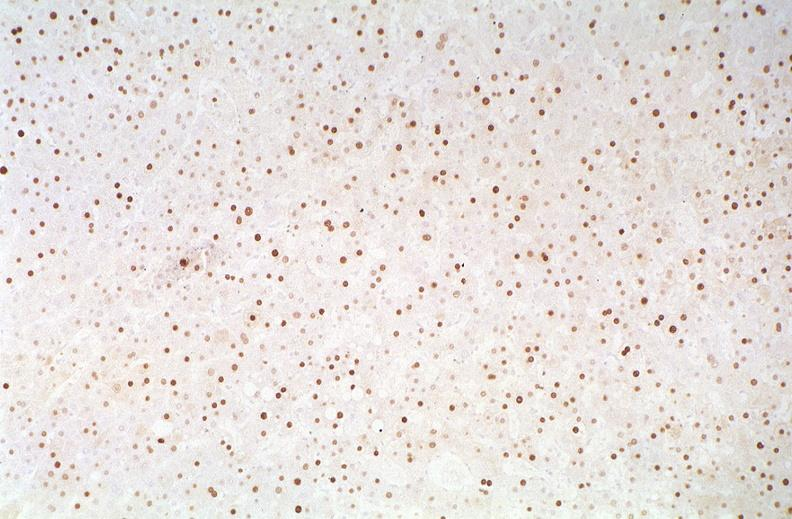s optic nerve present?
Answer the question using a single word or phrase. No 